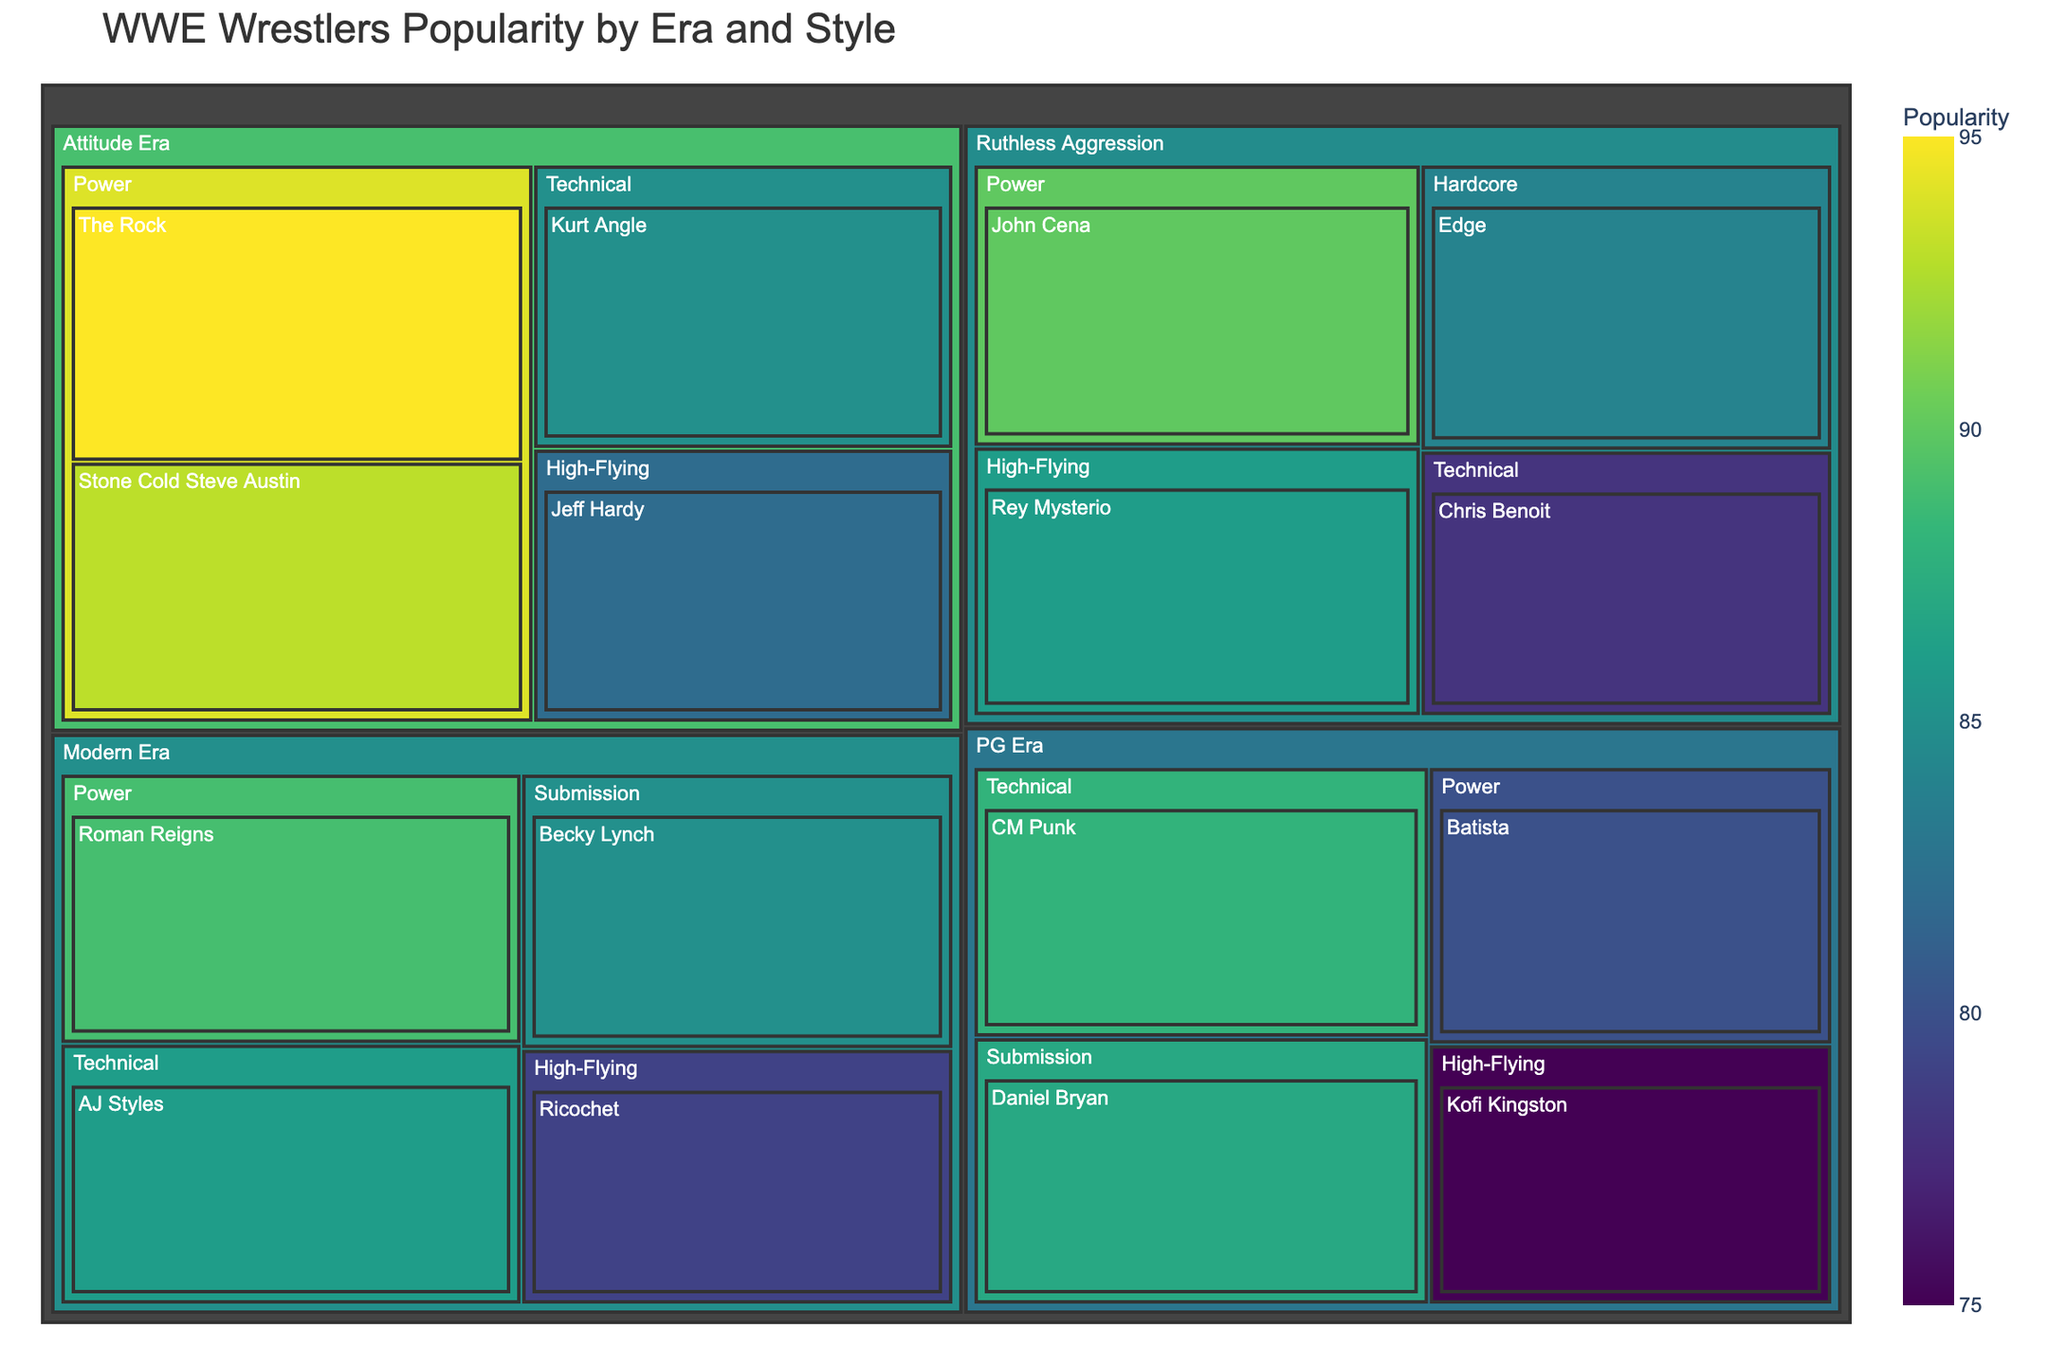What is the most popular wrestler in the Attitude Era? By looking at the Attitude Era section and identifying the wrestler with the highest popularity value, we can see that The Rock has the highest popularity with a value of 95.
Answer: The Rock Which wrestling style is most common in the PG Era? By identifying the number of wrestlers in each style category under the PG Era section, we see there are four styles: Power, Technical, High-Flying, and Submission, with one wrestler in each. Thus, no style is more common than another.
Answer: No style is more common Who is the most popular High-Flying wrestler across all eras? To determine this, we need to find the highest popularity value among High-Flying wrestlers in all eras. Jeff Hardy in the Attitude Era has the highest popularity at 82.
Answer: Jeff Hardy What is the difference in popularity between Roman Reigns and John Cena? Roman Reigns' popularity in the Modern Era is 89, and John Cena's popularity in the Ruthless Aggression era is 90. The difference is 90 - 89 = 1.
Answer: 1 Which era has the highest overall popularity among its wrestlers? Calculate the total popularity for each era by summing up the popularity values of all wrestlers in each era. Attitude Era: 95+93+85+82 = 355, Ruthless Aggression: 90+78+86+84 = 338, PG Era: 80+88+75+87 = 330, Modern Era: 89+86+79+85 = 339. The Attitude Era has the highest total popularity of 355.
Answer: Attitude Era Between the wrestlers in the Technical category, who has the second highest popularity? By comparing the popularity values of wrestlers in the Technical category across all eras, we see Kurt Angle (85), Chris Benoit (78), CM Punk (88), and AJ Styles (86). The second highest is AJ Styles with 86.
Answer: AJ Styles Who is more popular: Becky Lynch in the Modern Era or Edge in the Ruthless Aggression Era? Becky Lynch's popularity is 85, and Edge's popularity is 84. Becky Lynch is more popular as 85 > 84.
Answer: Becky Lynch How many total wrestlers are there in the Modern Era? By counting the number of wrestlers listed under the Modern Era section, we see there are 4 wrestlers (Roman Reigns, AJ Styles, Ricochet, Becky Lynch).
Answer: 4 